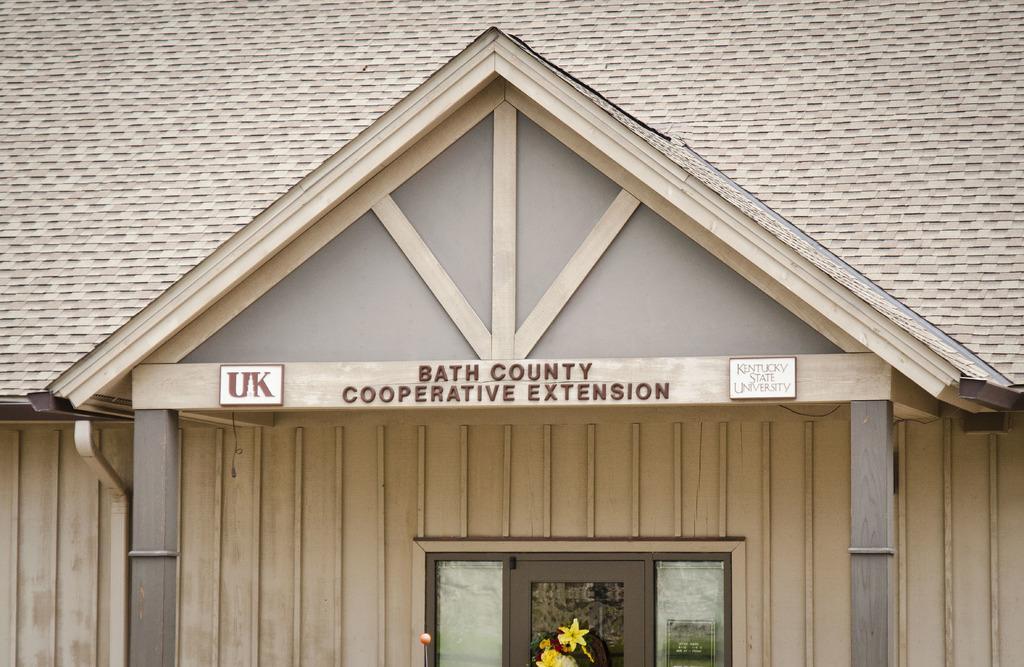In one or two sentences, can you explain what this image depicts? In this image there is a building, there is text on the building, there are boards, there is text on the boards, there are windows towards the bottom of the image, there is an object towards the bottom of the image, there are flowers, there is a wall. 